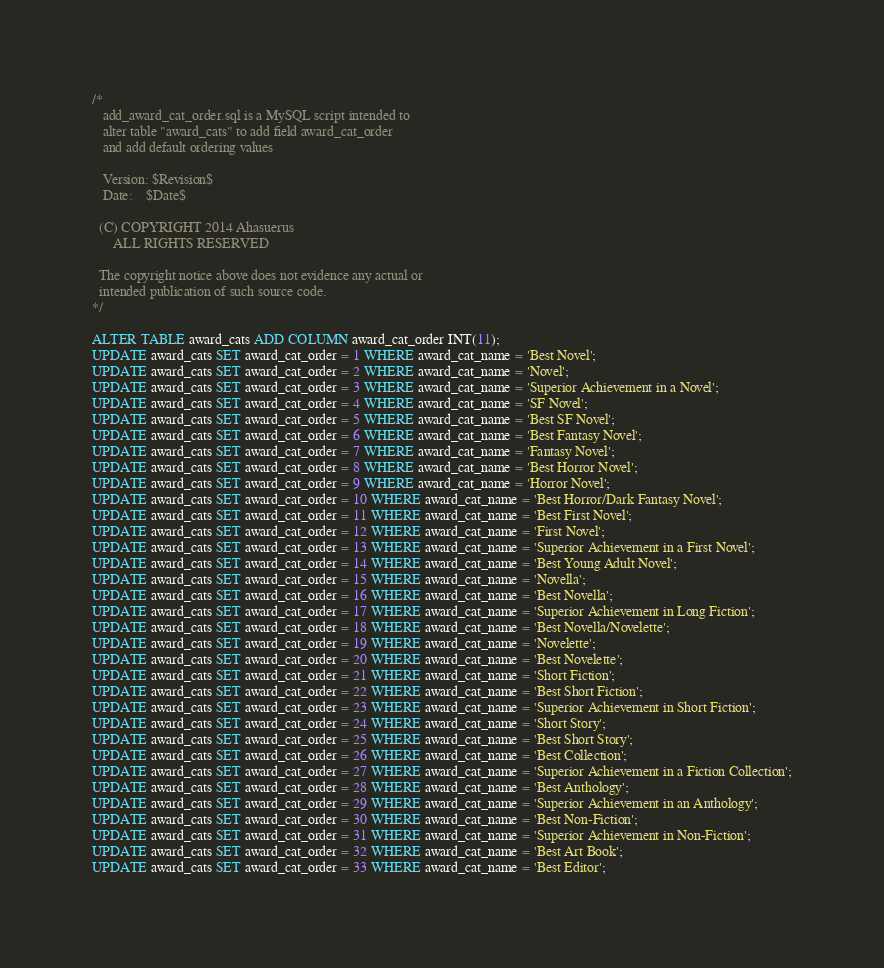Convert code to text. <code><loc_0><loc_0><loc_500><loc_500><_SQL_>/* 
   add_award_cat_order.sql is a MySQL script intended to
   alter table "award_cats" to add field award_cat_order
   and add default ordering values

   Version: $Revision$
   Date:    $Date$

  (C) COPYRIGHT 2014 Ahasuerus
      ALL RIGHTS RESERVED

  The copyright notice above does not evidence any actual or
  intended publication of such source code.
*/

ALTER TABLE award_cats ADD COLUMN award_cat_order INT(11);
UPDATE award_cats SET award_cat_order = 1 WHERE award_cat_name = 'Best Novel';
UPDATE award_cats SET award_cat_order = 2 WHERE award_cat_name = 'Novel';
UPDATE award_cats SET award_cat_order = 3 WHERE award_cat_name = 'Superior Achievement in a Novel';
UPDATE award_cats SET award_cat_order = 4 WHERE award_cat_name = 'SF Novel';
UPDATE award_cats SET award_cat_order = 5 WHERE award_cat_name = 'Best SF Novel';
UPDATE award_cats SET award_cat_order = 6 WHERE award_cat_name = 'Best Fantasy Novel';
UPDATE award_cats SET award_cat_order = 7 WHERE award_cat_name = 'Fantasy Novel';
UPDATE award_cats SET award_cat_order = 8 WHERE award_cat_name = 'Best Horror Novel';
UPDATE award_cats SET award_cat_order = 9 WHERE award_cat_name = 'Horror Novel';
UPDATE award_cats SET award_cat_order = 10 WHERE award_cat_name = 'Best Horror/Dark Fantasy Novel';
UPDATE award_cats SET award_cat_order = 11 WHERE award_cat_name = 'Best First Novel';
UPDATE award_cats SET award_cat_order = 12 WHERE award_cat_name = 'First Novel';
UPDATE award_cats SET award_cat_order = 13 WHERE award_cat_name = 'Superior Achievement in a First Novel';
UPDATE award_cats SET award_cat_order = 14 WHERE award_cat_name = 'Best Young Adult Novel';
UPDATE award_cats SET award_cat_order = 15 WHERE award_cat_name = 'Novella';
UPDATE award_cats SET award_cat_order = 16 WHERE award_cat_name = 'Best Novella';
UPDATE award_cats SET award_cat_order = 17 WHERE award_cat_name = 'Superior Achievement in Long Fiction';
UPDATE award_cats SET award_cat_order = 18 WHERE award_cat_name = 'Best Novella/Novelette';
UPDATE award_cats SET award_cat_order = 19 WHERE award_cat_name = 'Novelette';
UPDATE award_cats SET award_cat_order = 20 WHERE award_cat_name = 'Best Novelette';
UPDATE award_cats SET award_cat_order = 21 WHERE award_cat_name = 'Short Fiction';
UPDATE award_cats SET award_cat_order = 22 WHERE award_cat_name = 'Best Short Fiction';
UPDATE award_cats SET award_cat_order = 23 WHERE award_cat_name = 'Superior Achievement in Short Fiction';
UPDATE award_cats SET award_cat_order = 24 WHERE award_cat_name = 'Short Story';
UPDATE award_cats SET award_cat_order = 25 WHERE award_cat_name = 'Best Short Story';
UPDATE award_cats SET award_cat_order = 26 WHERE award_cat_name = 'Best Collection';
UPDATE award_cats SET award_cat_order = 27 WHERE award_cat_name = 'Superior Achievement in a Fiction Collection';
UPDATE award_cats SET award_cat_order = 28 WHERE award_cat_name = 'Best Anthology';
UPDATE award_cats SET award_cat_order = 29 WHERE award_cat_name = 'Superior Achievement in an Anthology';
UPDATE award_cats SET award_cat_order = 30 WHERE award_cat_name = 'Best Non-Fiction';
UPDATE award_cats SET award_cat_order = 31 WHERE award_cat_name = 'Superior Achievement in Non-Fiction';
UPDATE award_cats SET award_cat_order = 32 WHERE award_cat_name = 'Best Art Book';
UPDATE award_cats SET award_cat_order = 33 WHERE award_cat_name = 'Best Editor';</code> 